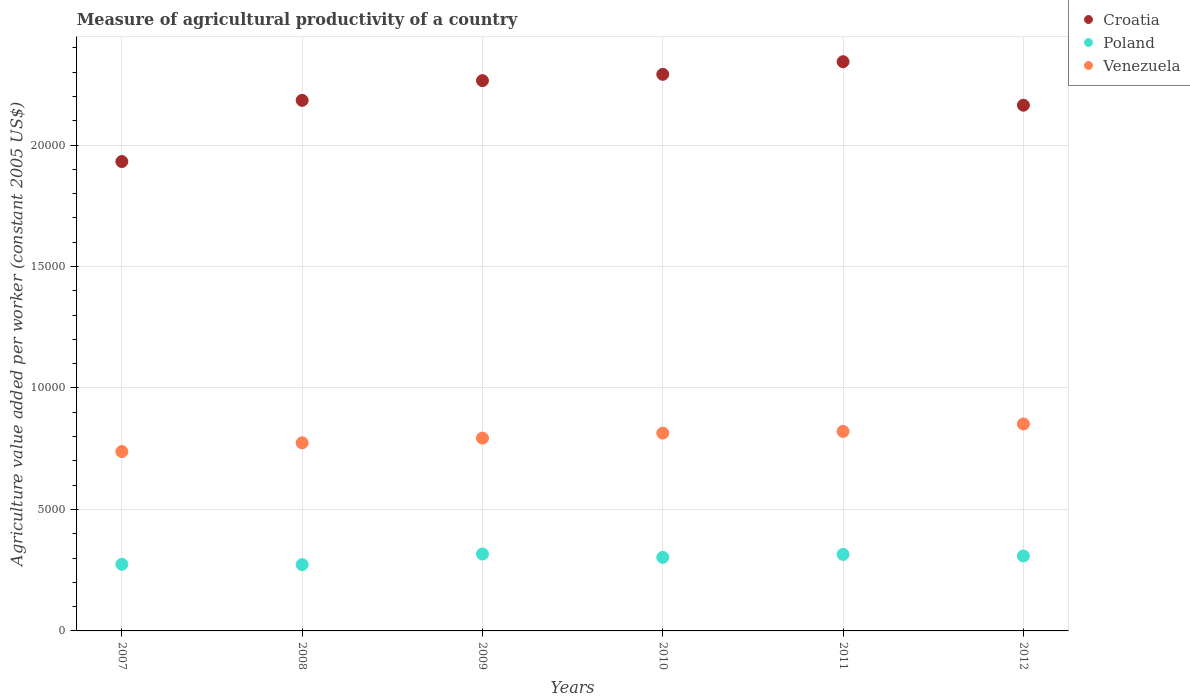How many different coloured dotlines are there?
Ensure brevity in your answer.  3. Is the number of dotlines equal to the number of legend labels?
Give a very brief answer. Yes. What is the measure of agricultural productivity in Croatia in 2011?
Your answer should be very brief. 2.34e+04. Across all years, what is the maximum measure of agricultural productivity in Croatia?
Ensure brevity in your answer.  2.34e+04. Across all years, what is the minimum measure of agricultural productivity in Croatia?
Provide a short and direct response. 1.93e+04. In which year was the measure of agricultural productivity in Poland maximum?
Ensure brevity in your answer.  2009. What is the total measure of agricultural productivity in Croatia in the graph?
Your response must be concise. 1.32e+05. What is the difference between the measure of agricultural productivity in Croatia in 2007 and that in 2011?
Offer a very short reply. -4109.16. What is the difference between the measure of agricultural productivity in Croatia in 2009 and the measure of agricultural productivity in Venezuela in 2007?
Keep it short and to the point. 1.53e+04. What is the average measure of agricultural productivity in Croatia per year?
Your answer should be very brief. 2.20e+04. In the year 2012, what is the difference between the measure of agricultural productivity in Poland and measure of agricultural productivity in Croatia?
Ensure brevity in your answer.  -1.86e+04. In how many years, is the measure of agricultural productivity in Venezuela greater than 23000 US$?
Your answer should be very brief. 0. What is the ratio of the measure of agricultural productivity in Venezuela in 2008 to that in 2012?
Provide a succinct answer. 0.91. Is the difference between the measure of agricultural productivity in Poland in 2007 and 2011 greater than the difference between the measure of agricultural productivity in Croatia in 2007 and 2011?
Ensure brevity in your answer.  Yes. What is the difference between the highest and the second highest measure of agricultural productivity in Croatia?
Provide a succinct answer. 519.55. What is the difference between the highest and the lowest measure of agricultural productivity in Croatia?
Your answer should be compact. 4109.16. In how many years, is the measure of agricultural productivity in Venezuela greater than the average measure of agricultural productivity in Venezuela taken over all years?
Your response must be concise. 3. Is the sum of the measure of agricultural productivity in Poland in 2008 and 2009 greater than the maximum measure of agricultural productivity in Croatia across all years?
Offer a very short reply. No. Is it the case that in every year, the sum of the measure of agricultural productivity in Croatia and measure of agricultural productivity in Venezuela  is greater than the measure of agricultural productivity in Poland?
Your response must be concise. Yes. Is the measure of agricultural productivity in Croatia strictly greater than the measure of agricultural productivity in Poland over the years?
Provide a short and direct response. Yes. Is the measure of agricultural productivity in Croatia strictly less than the measure of agricultural productivity in Poland over the years?
Your response must be concise. No. How many dotlines are there?
Make the answer very short. 3. What is the difference between two consecutive major ticks on the Y-axis?
Your answer should be compact. 5000. Are the values on the major ticks of Y-axis written in scientific E-notation?
Your response must be concise. No. Does the graph contain grids?
Offer a very short reply. Yes. What is the title of the graph?
Offer a terse response. Measure of agricultural productivity of a country. What is the label or title of the X-axis?
Provide a succinct answer. Years. What is the label or title of the Y-axis?
Keep it short and to the point. Agriculture value added per worker (constant 2005 US$). What is the Agriculture value added per worker (constant 2005 US$) in Croatia in 2007?
Offer a terse response. 1.93e+04. What is the Agriculture value added per worker (constant 2005 US$) of Poland in 2007?
Give a very brief answer. 2742.76. What is the Agriculture value added per worker (constant 2005 US$) in Venezuela in 2007?
Your answer should be very brief. 7381.74. What is the Agriculture value added per worker (constant 2005 US$) in Croatia in 2008?
Your response must be concise. 2.18e+04. What is the Agriculture value added per worker (constant 2005 US$) in Poland in 2008?
Your answer should be very brief. 2729.29. What is the Agriculture value added per worker (constant 2005 US$) in Venezuela in 2008?
Provide a succinct answer. 7741.56. What is the Agriculture value added per worker (constant 2005 US$) in Croatia in 2009?
Your answer should be very brief. 2.26e+04. What is the Agriculture value added per worker (constant 2005 US$) of Poland in 2009?
Give a very brief answer. 3163.61. What is the Agriculture value added per worker (constant 2005 US$) of Venezuela in 2009?
Give a very brief answer. 7936.15. What is the Agriculture value added per worker (constant 2005 US$) of Croatia in 2010?
Provide a short and direct response. 2.29e+04. What is the Agriculture value added per worker (constant 2005 US$) in Poland in 2010?
Your answer should be very brief. 3027.83. What is the Agriculture value added per worker (constant 2005 US$) in Venezuela in 2010?
Give a very brief answer. 8142.26. What is the Agriculture value added per worker (constant 2005 US$) in Croatia in 2011?
Your answer should be very brief. 2.34e+04. What is the Agriculture value added per worker (constant 2005 US$) of Poland in 2011?
Provide a short and direct response. 3149.7. What is the Agriculture value added per worker (constant 2005 US$) of Venezuela in 2011?
Offer a very short reply. 8212.05. What is the Agriculture value added per worker (constant 2005 US$) in Croatia in 2012?
Keep it short and to the point. 2.16e+04. What is the Agriculture value added per worker (constant 2005 US$) in Poland in 2012?
Provide a short and direct response. 3084.53. What is the Agriculture value added per worker (constant 2005 US$) in Venezuela in 2012?
Provide a succinct answer. 8518.63. Across all years, what is the maximum Agriculture value added per worker (constant 2005 US$) in Croatia?
Make the answer very short. 2.34e+04. Across all years, what is the maximum Agriculture value added per worker (constant 2005 US$) in Poland?
Provide a short and direct response. 3163.61. Across all years, what is the maximum Agriculture value added per worker (constant 2005 US$) of Venezuela?
Provide a succinct answer. 8518.63. Across all years, what is the minimum Agriculture value added per worker (constant 2005 US$) in Croatia?
Give a very brief answer. 1.93e+04. Across all years, what is the minimum Agriculture value added per worker (constant 2005 US$) in Poland?
Your answer should be very brief. 2729.29. Across all years, what is the minimum Agriculture value added per worker (constant 2005 US$) in Venezuela?
Keep it short and to the point. 7381.74. What is the total Agriculture value added per worker (constant 2005 US$) of Croatia in the graph?
Your response must be concise. 1.32e+05. What is the total Agriculture value added per worker (constant 2005 US$) of Poland in the graph?
Offer a terse response. 1.79e+04. What is the total Agriculture value added per worker (constant 2005 US$) of Venezuela in the graph?
Offer a very short reply. 4.79e+04. What is the difference between the Agriculture value added per worker (constant 2005 US$) in Croatia in 2007 and that in 2008?
Offer a terse response. -2518.83. What is the difference between the Agriculture value added per worker (constant 2005 US$) in Poland in 2007 and that in 2008?
Make the answer very short. 13.46. What is the difference between the Agriculture value added per worker (constant 2005 US$) in Venezuela in 2007 and that in 2008?
Your response must be concise. -359.82. What is the difference between the Agriculture value added per worker (constant 2005 US$) of Croatia in 2007 and that in 2009?
Provide a short and direct response. -3330.51. What is the difference between the Agriculture value added per worker (constant 2005 US$) of Poland in 2007 and that in 2009?
Your response must be concise. -420.85. What is the difference between the Agriculture value added per worker (constant 2005 US$) of Venezuela in 2007 and that in 2009?
Keep it short and to the point. -554.41. What is the difference between the Agriculture value added per worker (constant 2005 US$) in Croatia in 2007 and that in 2010?
Make the answer very short. -3589.61. What is the difference between the Agriculture value added per worker (constant 2005 US$) in Poland in 2007 and that in 2010?
Give a very brief answer. -285.07. What is the difference between the Agriculture value added per worker (constant 2005 US$) in Venezuela in 2007 and that in 2010?
Make the answer very short. -760.52. What is the difference between the Agriculture value added per worker (constant 2005 US$) in Croatia in 2007 and that in 2011?
Provide a short and direct response. -4109.16. What is the difference between the Agriculture value added per worker (constant 2005 US$) of Poland in 2007 and that in 2011?
Give a very brief answer. -406.94. What is the difference between the Agriculture value added per worker (constant 2005 US$) of Venezuela in 2007 and that in 2011?
Your response must be concise. -830.31. What is the difference between the Agriculture value added per worker (constant 2005 US$) in Croatia in 2007 and that in 2012?
Your answer should be compact. -2318.98. What is the difference between the Agriculture value added per worker (constant 2005 US$) in Poland in 2007 and that in 2012?
Give a very brief answer. -341.78. What is the difference between the Agriculture value added per worker (constant 2005 US$) of Venezuela in 2007 and that in 2012?
Your answer should be very brief. -1136.89. What is the difference between the Agriculture value added per worker (constant 2005 US$) in Croatia in 2008 and that in 2009?
Your answer should be very brief. -811.68. What is the difference between the Agriculture value added per worker (constant 2005 US$) in Poland in 2008 and that in 2009?
Keep it short and to the point. -434.31. What is the difference between the Agriculture value added per worker (constant 2005 US$) of Venezuela in 2008 and that in 2009?
Keep it short and to the point. -194.59. What is the difference between the Agriculture value added per worker (constant 2005 US$) in Croatia in 2008 and that in 2010?
Your response must be concise. -1070.77. What is the difference between the Agriculture value added per worker (constant 2005 US$) in Poland in 2008 and that in 2010?
Make the answer very short. -298.54. What is the difference between the Agriculture value added per worker (constant 2005 US$) of Venezuela in 2008 and that in 2010?
Keep it short and to the point. -400.7. What is the difference between the Agriculture value added per worker (constant 2005 US$) of Croatia in 2008 and that in 2011?
Keep it short and to the point. -1590.33. What is the difference between the Agriculture value added per worker (constant 2005 US$) in Poland in 2008 and that in 2011?
Your response must be concise. -420.4. What is the difference between the Agriculture value added per worker (constant 2005 US$) of Venezuela in 2008 and that in 2011?
Offer a very short reply. -470.49. What is the difference between the Agriculture value added per worker (constant 2005 US$) of Croatia in 2008 and that in 2012?
Provide a succinct answer. 199.86. What is the difference between the Agriculture value added per worker (constant 2005 US$) of Poland in 2008 and that in 2012?
Provide a succinct answer. -355.24. What is the difference between the Agriculture value added per worker (constant 2005 US$) in Venezuela in 2008 and that in 2012?
Your answer should be very brief. -777.07. What is the difference between the Agriculture value added per worker (constant 2005 US$) of Croatia in 2009 and that in 2010?
Your response must be concise. -259.09. What is the difference between the Agriculture value added per worker (constant 2005 US$) in Poland in 2009 and that in 2010?
Your answer should be compact. 135.78. What is the difference between the Agriculture value added per worker (constant 2005 US$) of Venezuela in 2009 and that in 2010?
Offer a very short reply. -206.11. What is the difference between the Agriculture value added per worker (constant 2005 US$) of Croatia in 2009 and that in 2011?
Your answer should be very brief. -778.64. What is the difference between the Agriculture value added per worker (constant 2005 US$) in Poland in 2009 and that in 2011?
Your response must be concise. 13.91. What is the difference between the Agriculture value added per worker (constant 2005 US$) of Venezuela in 2009 and that in 2011?
Your response must be concise. -275.89. What is the difference between the Agriculture value added per worker (constant 2005 US$) of Croatia in 2009 and that in 2012?
Provide a short and direct response. 1011.54. What is the difference between the Agriculture value added per worker (constant 2005 US$) in Poland in 2009 and that in 2012?
Offer a very short reply. 79.07. What is the difference between the Agriculture value added per worker (constant 2005 US$) of Venezuela in 2009 and that in 2012?
Provide a succinct answer. -582.47. What is the difference between the Agriculture value added per worker (constant 2005 US$) in Croatia in 2010 and that in 2011?
Offer a very short reply. -519.55. What is the difference between the Agriculture value added per worker (constant 2005 US$) of Poland in 2010 and that in 2011?
Provide a succinct answer. -121.87. What is the difference between the Agriculture value added per worker (constant 2005 US$) of Venezuela in 2010 and that in 2011?
Provide a short and direct response. -69.79. What is the difference between the Agriculture value added per worker (constant 2005 US$) in Croatia in 2010 and that in 2012?
Ensure brevity in your answer.  1270.63. What is the difference between the Agriculture value added per worker (constant 2005 US$) in Poland in 2010 and that in 2012?
Make the answer very short. -56.7. What is the difference between the Agriculture value added per worker (constant 2005 US$) of Venezuela in 2010 and that in 2012?
Offer a terse response. -376.36. What is the difference between the Agriculture value added per worker (constant 2005 US$) in Croatia in 2011 and that in 2012?
Give a very brief answer. 1790.18. What is the difference between the Agriculture value added per worker (constant 2005 US$) of Poland in 2011 and that in 2012?
Your response must be concise. 65.16. What is the difference between the Agriculture value added per worker (constant 2005 US$) in Venezuela in 2011 and that in 2012?
Your response must be concise. -306.58. What is the difference between the Agriculture value added per worker (constant 2005 US$) of Croatia in 2007 and the Agriculture value added per worker (constant 2005 US$) of Poland in 2008?
Provide a succinct answer. 1.66e+04. What is the difference between the Agriculture value added per worker (constant 2005 US$) in Croatia in 2007 and the Agriculture value added per worker (constant 2005 US$) in Venezuela in 2008?
Keep it short and to the point. 1.16e+04. What is the difference between the Agriculture value added per worker (constant 2005 US$) in Poland in 2007 and the Agriculture value added per worker (constant 2005 US$) in Venezuela in 2008?
Provide a short and direct response. -4998.8. What is the difference between the Agriculture value added per worker (constant 2005 US$) of Croatia in 2007 and the Agriculture value added per worker (constant 2005 US$) of Poland in 2009?
Keep it short and to the point. 1.62e+04. What is the difference between the Agriculture value added per worker (constant 2005 US$) of Croatia in 2007 and the Agriculture value added per worker (constant 2005 US$) of Venezuela in 2009?
Ensure brevity in your answer.  1.14e+04. What is the difference between the Agriculture value added per worker (constant 2005 US$) of Poland in 2007 and the Agriculture value added per worker (constant 2005 US$) of Venezuela in 2009?
Provide a short and direct response. -5193.4. What is the difference between the Agriculture value added per worker (constant 2005 US$) of Croatia in 2007 and the Agriculture value added per worker (constant 2005 US$) of Poland in 2010?
Keep it short and to the point. 1.63e+04. What is the difference between the Agriculture value added per worker (constant 2005 US$) of Croatia in 2007 and the Agriculture value added per worker (constant 2005 US$) of Venezuela in 2010?
Provide a short and direct response. 1.12e+04. What is the difference between the Agriculture value added per worker (constant 2005 US$) of Poland in 2007 and the Agriculture value added per worker (constant 2005 US$) of Venezuela in 2010?
Offer a terse response. -5399.51. What is the difference between the Agriculture value added per worker (constant 2005 US$) in Croatia in 2007 and the Agriculture value added per worker (constant 2005 US$) in Poland in 2011?
Your answer should be compact. 1.62e+04. What is the difference between the Agriculture value added per worker (constant 2005 US$) in Croatia in 2007 and the Agriculture value added per worker (constant 2005 US$) in Venezuela in 2011?
Your answer should be compact. 1.11e+04. What is the difference between the Agriculture value added per worker (constant 2005 US$) in Poland in 2007 and the Agriculture value added per worker (constant 2005 US$) in Venezuela in 2011?
Your answer should be very brief. -5469.29. What is the difference between the Agriculture value added per worker (constant 2005 US$) in Croatia in 2007 and the Agriculture value added per worker (constant 2005 US$) in Poland in 2012?
Provide a short and direct response. 1.62e+04. What is the difference between the Agriculture value added per worker (constant 2005 US$) of Croatia in 2007 and the Agriculture value added per worker (constant 2005 US$) of Venezuela in 2012?
Offer a terse response. 1.08e+04. What is the difference between the Agriculture value added per worker (constant 2005 US$) of Poland in 2007 and the Agriculture value added per worker (constant 2005 US$) of Venezuela in 2012?
Ensure brevity in your answer.  -5775.87. What is the difference between the Agriculture value added per worker (constant 2005 US$) of Croatia in 2008 and the Agriculture value added per worker (constant 2005 US$) of Poland in 2009?
Your answer should be very brief. 1.87e+04. What is the difference between the Agriculture value added per worker (constant 2005 US$) of Croatia in 2008 and the Agriculture value added per worker (constant 2005 US$) of Venezuela in 2009?
Your response must be concise. 1.39e+04. What is the difference between the Agriculture value added per worker (constant 2005 US$) in Poland in 2008 and the Agriculture value added per worker (constant 2005 US$) in Venezuela in 2009?
Your answer should be compact. -5206.86. What is the difference between the Agriculture value added per worker (constant 2005 US$) in Croatia in 2008 and the Agriculture value added per worker (constant 2005 US$) in Poland in 2010?
Offer a very short reply. 1.88e+04. What is the difference between the Agriculture value added per worker (constant 2005 US$) of Croatia in 2008 and the Agriculture value added per worker (constant 2005 US$) of Venezuela in 2010?
Offer a terse response. 1.37e+04. What is the difference between the Agriculture value added per worker (constant 2005 US$) in Poland in 2008 and the Agriculture value added per worker (constant 2005 US$) in Venezuela in 2010?
Your response must be concise. -5412.97. What is the difference between the Agriculture value added per worker (constant 2005 US$) of Croatia in 2008 and the Agriculture value added per worker (constant 2005 US$) of Poland in 2011?
Offer a very short reply. 1.87e+04. What is the difference between the Agriculture value added per worker (constant 2005 US$) of Croatia in 2008 and the Agriculture value added per worker (constant 2005 US$) of Venezuela in 2011?
Ensure brevity in your answer.  1.36e+04. What is the difference between the Agriculture value added per worker (constant 2005 US$) in Poland in 2008 and the Agriculture value added per worker (constant 2005 US$) in Venezuela in 2011?
Your response must be concise. -5482.76. What is the difference between the Agriculture value added per worker (constant 2005 US$) in Croatia in 2008 and the Agriculture value added per worker (constant 2005 US$) in Poland in 2012?
Ensure brevity in your answer.  1.88e+04. What is the difference between the Agriculture value added per worker (constant 2005 US$) in Croatia in 2008 and the Agriculture value added per worker (constant 2005 US$) in Venezuela in 2012?
Offer a terse response. 1.33e+04. What is the difference between the Agriculture value added per worker (constant 2005 US$) of Poland in 2008 and the Agriculture value added per worker (constant 2005 US$) of Venezuela in 2012?
Your answer should be compact. -5789.33. What is the difference between the Agriculture value added per worker (constant 2005 US$) in Croatia in 2009 and the Agriculture value added per worker (constant 2005 US$) in Poland in 2010?
Ensure brevity in your answer.  1.96e+04. What is the difference between the Agriculture value added per worker (constant 2005 US$) of Croatia in 2009 and the Agriculture value added per worker (constant 2005 US$) of Venezuela in 2010?
Offer a terse response. 1.45e+04. What is the difference between the Agriculture value added per worker (constant 2005 US$) in Poland in 2009 and the Agriculture value added per worker (constant 2005 US$) in Venezuela in 2010?
Give a very brief answer. -4978.66. What is the difference between the Agriculture value added per worker (constant 2005 US$) in Croatia in 2009 and the Agriculture value added per worker (constant 2005 US$) in Poland in 2011?
Your response must be concise. 1.95e+04. What is the difference between the Agriculture value added per worker (constant 2005 US$) in Croatia in 2009 and the Agriculture value added per worker (constant 2005 US$) in Venezuela in 2011?
Offer a very short reply. 1.44e+04. What is the difference between the Agriculture value added per worker (constant 2005 US$) of Poland in 2009 and the Agriculture value added per worker (constant 2005 US$) of Venezuela in 2011?
Keep it short and to the point. -5048.44. What is the difference between the Agriculture value added per worker (constant 2005 US$) of Croatia in 2009 and the Agriculture value added per worker (constant 2005 US$) of Poland in 2012?
Offer a very short reply. 1.96e+04. What is the difference between the Agriculture value added per worker (constant 2005 US$) of Croatia in 2009 and the Agriculture value added per worker (constant 2005 US$) of Venezuela in 2012?
Keep it short and to the point. 1.41e+04. What is the difference between the Agriculture value added per worker (constant 2005 US$) in Poland in 2009 and the Agriculture value added per worker (constant 2005 US$) in Venezuela in 2012?
Keep it short and to the point. -5355.02. What is the difference between the Agriculture value added per worker (constant 2005 US$) of Croatia in 2010 and the Agriculture value added per worker (constant 2005 US$) of Poland in 2011?
Offer a very short reply. 1.98e+04. What is the difference between the Agriculture value added per worker (constant 2005 US$) in Croatia in 2010 and the Agriculture value added per worker (constant 2005 US$) in Venezuela in 2011?
Ensure brevity in your answer.  1.47e+04. What is the difference between the Agriculture value added per worker (constant 2005 US$) in Poland in 2010 and the Agriculture value added per worker (constant 2005 US$) in Venezuela in 2011?
Provide a short and direct response. -5184.22. What is the difference between the Agriculture value added per worker (constant 2005 US$) in Croatia in 2010 and the Agriculture value added per worker (constant 2005 US$) in Poland in 2012?
Your response must be concise. 1.98e+04. What is the difference between the Agriculture value added per worker (constant 2005 US$) of Croatia in 2010 and the Agriculture value added per worker (constant 2005 US$) of Venezuela in 2012?
Your answer should be compact. 1.44e+04. What is the difference between the Agriculture value added per worker (constant 2005 US$) of Poland in 2010 and the Agriculture value added per worker (constant 2005 US$) of Venezuela in 2012?
Make the answer very short. -5490.8. What is the difference between the Agriculture value added per worker (constant 2005 US$) of Croatia in 2011 and the Agriculture value added per worker (constant 2005 US$) of Poland in 2012?
Offer a very short reply. 2.03e+04. What is the difference between the Agriculture value added per worker (constant 2005 US$) in Croatia in 2011 and the Agriculture value added per worker (constant 2005 US$) in Venezuela in 2012?
Your answer should be compact. 1.49e+04. What is the difference between the Agriculture value added per worker (constant 2005 US$) of Poland in 2011 and the Agriculture value added per worker (constant 2005 US$) of Venezuela in 2012?
Your answer should be compact. -5368.93. What is the average Agriculture value added per worker (constant 2005 US$) in Croatia per year?
Your answer should be compact. 2.20e+04. What is the average Agriculture value added per worker (constant 2005 US$) of Poland per year?
Give a very brief answer. 2982.95. What is the average Agriculture value added per worker (constant 2005 US$) in Venezuela per year?
Provide a succinct answer. 7988.73. In the year 2007, what is the difference between the Agriculture value added per worker (constant 2005 US$) in Croatia and Agriculture value added per worker (constant 2005 US$) in Poland?
Your response must be concise. 1.66e+04. In the year 2007, what is the difference between the Agriculture value added per worker (constant 2005 US$) of Croatia and Agriculture value added per worker (constant 2005 US$) of Venezuela?
Keep it short and to the point. 1.19e+04. In the year 2007, what is the difference between the Agriculture value added per worker (constant 2005 US$) in Poland and Agriculture value added per worker (constant 2005 US$) in Venezuela?
Keep it short and to the point. -4638.99. In the year 2008, what is the difference between the Agriculture value added per worker (constant 2005 US$) of Croatia and Agriculture value added per worker (constant 2005 US$) of Poland?
Offer a terse response. 1.91e+04. In the year 2008, what is the difference between the Agriculture value added per worker (constant 2005 US$) of Croatia and Agriculture value added per worker (constant 2005 US$) of Venezuela?
Keep it short and to the point. 1.41e+04. In the year 2008, what is the difference between the Agriculture value added per worker (constant 2005 US$) in Poland and Agriculture value added per worker (constant 2005 US$) in Venezuela?
Your response must be concise. -5012.27. In the year 2009, what is the difference between the Agriculture value added per worker (constant 2005 US$) in Croatia and Agriculture value added per worker (constant 2005 US$) in Poland?
Provide a short and direct response. 1.95e+04. In the year 2009, what is the difference between the Agriculture value added per worker (constant 2005 US$) of Croatia and Agriculture value added per worker (constant 2005 US$) of Venezuela?
Your response must be concise. 1.47e+04. In the year 2009, what is the difference between the Agriculture value added per worker (constant 2005 US$) in Poland and Agriculture value added per worker (constant 2005 US$) in Venezuela?
Keep it short and to the point. -4772.55. In the year 2010, what is the difference between the Agriculture value added per worker (constant 2005 US$) in Croatia and Agriculture value added per worker (constant 2005 US$) in Poland?
Make the answer very short. 1.99e+04. In the year 2010, what is the difference between the Agriculture value added per worker (constant 2005 US$) in Croatia and Agriculture value added per worker (constant 2005 US$) in Venezuela?
Give a very brief answer. 1.48e+04. In the year 2010, what is the difference between the Agriculture value added per worker (constant 2005 US$) of Poland and Agriculture value added per worker (constant 2005 US$) of Venezuela?
Keep it short and to the point. -5114.43. In the year 2011, what is the difference between the Agriculture value added per worker (constant 2005 US$) of Croatia and Agriculture value added per worker (constant 2005 US$) of Poland?
Ensure brevity in your answer.  2.03e+04. In the year 2011, what is the difference between the Agriculture value added per worker (constant 2005 US$) of Croatia and Agriculture value added per worker (constant 2005 US$) of Venezuela?
Your answer should be very brief. 1.52e+04. In the year 2011, what is the difference between the Agriculture value added per worker (constant 2005 US$) of Poland and Agriculture value added per worker (constant 2005 US$) of Venezuela?
Make the answer very short. -5062.35. In the year 2012, what is the difference between the Agriculture value added per worker (constant 2005 US$) in Croatia and Agriculture value added per worker (constant 2005 US$) in Poland?
Give a very brief answer. 1.86e+04. In the year 2012, what is the difference between the Agriculture value added per worker (constant 2005 US$) in Croatia and Agriculture value added per worker (constant 2005 US$) in Venezuela?
Your answer should be very brief. 1.31e+04. In the year 2012, what is the difference between the Agriculture value added per worker (constant 2005 US$) of Poland and Agriculture value added per worker (constant 2005 US$) of Venezuela?
Offer a very short reply. -5434.1. What is the ratio of the Agriculture value added per worker (constant 2005 US$) in Croatia in 2007 to that in 2008?
Your response must be concise. 0.88. What is the ratio of the Agriculture value added per worker (constant 2005 US$) in Venezuela in 2007 to that in 2008?
Ensure brevity in your answer.  0.95. What is the ratio of the Agriculture value added per worker (constant 2005 US$) in Croatia in 2007 to that in 2009?
Give a very brief answer. 0.85. What is the ratio of the Agriculture value added per worker (constant 2005 US$) in Poland in 2007 to that in 2009?
Give a very brief answer. 0.87. What is the ratio of the Agriculture value added per worker (constant 2005 US$) in Venezuela in 2007 to that in 2009?
Keep it short and to the point. 0.93. What is the ratio of the Agriculture value added per worker (constant 2005 US$) in Croatia in 2007 to that in 2010?
Offer a very short reply. 0.84. What is the ratio of the Agriculture value added per worker (constant 2005 US$) in Poland in 2007 to that in 2010?
Your response must be concise. 0.91. What is the ratio of the Agriculture value added per worker (constant 2005 US$) in Venezuela in 2007 to that in 2010?
Your answer should be compact. 0.91. What is the ratio of the Agriculture value added per worker (constant 2005 US$) of Croatia in 2007 to that in 2011?
Keep it short and to the point. 0.82. What is the ratio of the Agriculture value added per worker (constant 2005 US$) in Poland in 2007 to that in 2011?
Provide a short and direct response. 0.87. What is the ratio of the Agriculture value added per worker (constant 2005 US$) of Venezuela in 2007 to that in 2011?
Ensure brevity in your answer.  0.9. What is the ratio of the Agriculture value added per worker (constant 2005 US$) in Croatia in 2007 to that in 2012?
Your answer should be compact. 0.89. What is the ratio of the Agriculture value added per worker (constant 2005 US$) in Poland in 2007 to that in 2012?
Offer a very short reply. 0.89. What is the ratio of the Agriculture value added per worker (constant 2005 US$) in Venezuela in 2007 to that in 2012?
Provide a short and direct response. 0.87. What is the ratio of the Agriculture value added per worker (constant 2005 US$) in Croatia in 2008 to that in 2009?
Your answer should be very brief. 0.96. What is the ratio of the Agriculture value added per worker (constant 2005 US$) of Poland in 2008 to that in 2009?
Your answer should be very brief. 0.86. What is the ratio of the Agriculture value added per worker (constant 2005 US$) of Venezuela in 2008 to that in 2009?
Offer a very short reply. 0.98. What is the ratio of the Agriculture value added per worker (constant 2005 US$) in Croatia in 2008 to that in 2010?
Your answer should be very brief. 0.95. What is the ratio of the Agriculture value added per worker (constant 2005 US$) in Poland in 2008 to that in 2010?
Make the answer very short. 0.9. What is the ratio of the Agriculture value added per worker (constant 2005 US$) in Venezuela in 2008 to that in 2010?
Ensure brevity in your answer.  0.95. What is the ratio of the Agriculture value added per worker (constant 2005 US$) of Croatia in 2008 to that in 2011?
Offer a terse response. 0.93. What is the ratio of the Agriculture value added per worker (constant 2005 US$) of Poland in 2008 to that in 2011?
Your answer should be very brief. 0.87. What is the ratio of the Agriculture value added per worker (constant 2005 US$) of Venezuela in 2008 to that in 2011?
Offer a very short reply. 0.94. What is the ratio of the Agriculture value added per worker (constant 2005 US$) in Croatia in 2008 to that in 2012?
Your response must be concise. 1.01. What is the ratio of the Agriculture value added per worker (constant 2005 US$) in Poland in 2008 to that in 2012?
Offer a very short reply. 0.88. What is the ratio of the Agriculture value added per worker (constant 2005 US$) in Venezuela in 2008 to that in 2012?
Provide a short and direct response. 0.91. What is the ratio of the Agriculture value added per worker (constant 2005 US$) of Croatia in 2009 to that in 2010?
Offer a very short reply. 0.99. What is the ratio of the Agriculture value added per worker (constant 2005 US$) in Poland in 2009 to that in 2010?
Offer a very short reply. 1.04. What is the ratio of the Agriculture value added per worker (constant 2005 US$) of Venezuela in 2009 to that in 2010?
Provide a short and direct response. 0.97. What is the ratio of the Agriculture value added per worker (constant 2005 US$) in Croatia in 2009 to that in 2011?
Provide a succinct answer. 0.97. What is the ratio of the Agriculture value added per worker (constant 2005 US$) in Poland in 2009 to that in 2011?
Provide a short and direct response. 1. What is the ratio of the Agriculture value added per worker (constant 2005 US$) of Venezuela in 2009 to that in 2011?
Offer a terse response. 0.97. What is the ratio of the Agriculture value added per worker (constant 2005 US$) of Croatia in 2009 to that in 2012?
Give a very brief answer. 1.05. What is the ratio of the Agriculture value added per worker (constant 2005 US$) in Poland in 2009 to that in 2012?
Your answer should be very brief. 1.03. What is the ratio of the Agriculture value added per worker (constant 2005 US$) in Venezuela in 2009 to that in 2012?
Make the answer very short. 0.93. What is the ratio of the Agriculture value added per worker (constant 2005 US$) in Croatia in 2010 to that in 2011?
Keep it short and to the point. 0.98. What is the ratio of the Agriculture value added per worker (constant 2005 US$) of Poland in 2010 to that in 2011?
Keep it short and to the point. 0.96. What is the ratio of the Agriculture value added per worker (constant 2005 US$) of Croatia in 2010 to that in 2012?
Keep it short and to the point. 1.06. What is the ratio of the Agriculture value added per worker (constant 2005 US$) of Poland in 2010 to that in 2012?
Provide a short and direct response. 0.98. What is the ratio of the Agriculture value added per worker (constant 2005 US$) in Venezuela in 2010 to that in 2012?
Provide a succinct answer. 0.96. What is the ratio of the Agriculture value added per worker (constant 2005 US$) in Croatia in 2011 to that in 2012?
Your response must be concise. 1.08. What is the ratio of the Agriculture value added per worker (constant 2005 US$) in Poland in 2011 to that in 2012?
Give a very brief answer. 1.02. What is the ratio of the Agriculture value added per worker (constant 2005 US$) of Venezuela in 2011 to that in 2012?
Your answer should be compact. 0.96. What is the difference between the highest and the second highest Agriculture value added per worker (constant 2005 US$) of Croatia?
Offer a very short reply. 519.55. What is the difference between the highest and the second highest Agriculture value added per worker (constant 2005 US$) in Poland?
Give a very brief answer. 13.91. What is the difference between the highest and the second highest Agriculture value added per worker (constant 2005 US$) in Venezuela?
Offer a terse response. 306.58. What is the difference between the highest and the lowest Agriculture value added per worker (constant 2005 US$) of Croatia?
Keep it short and to the point. 4109.16. What is the difference between the highest and the lowest Agriculture value added per worker (constant 2005 US$) in Poland?
Offer a very short reply. 434.31. What is the difference between the highest and the lowest Agriculture value added per worker (constant 2005 US$) in Venezuela?
Keep it short and to the point. 1136.89. 